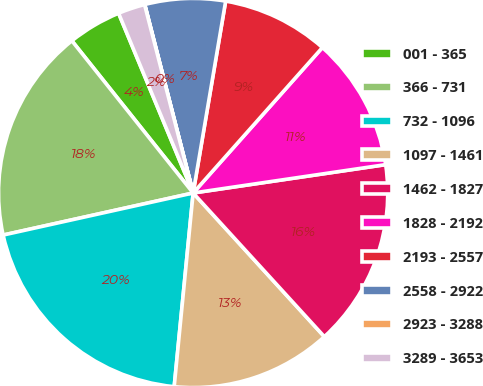<chart> <loc_0><loc_0><loc_500><loc_500><pie_chart><fcel>001 - 365<fcel>366 - 731<fcel>732 - 1096<fcel>1097 - 1461<fcel>1462 - 1827<fcel>1828 - 2192<fcel>2193 - 2557<fcel>2558 - 2922<fcel>2923 - 3288<fcel>3289 - 3653<nl><fcel>4.45%<fcel>17.76%<fcel>19.98%<fcel>13.33%<fcel>15.55%<fcel>11.11%<fcel>8.89%<fcel>6.67%<fcel>0.02%<fcel>2.24%<nl></chart> 